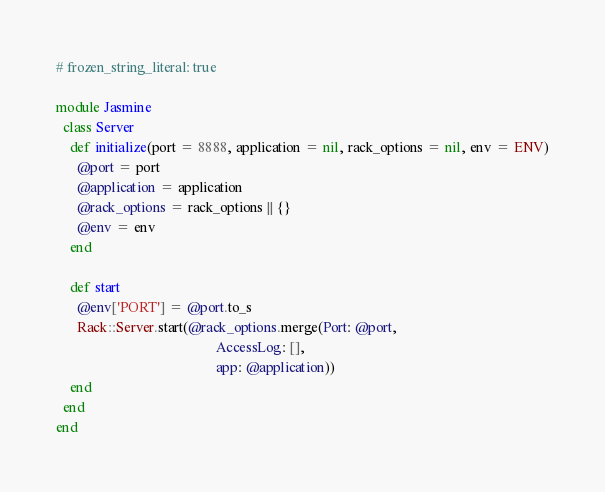Convert code to text. <code><loc_0><loc_0><loc_500><loc_500><_Ruby_># frozen_string_literal: true

module Jasmine
  class Server
    def initialize(port = 8888, application = nil, rack_options = nil, env = ENV)
      @port = port
      @application = application
      @rack_options = rack_options || {}
      @env = env
    end

    def start
      @env['PORT'] = @port.to_s
      Rack::Server.start(@rack_options.merge(Port: @port,
                                             AccessLog: [],
                                             app: @application))
    end
  end
end

</code> 